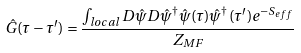Convert formula to latex. <formula><loc_0><loc_0><loc_500><loc_500>\hat { G } ( \tau - \tau ^ { \prime } ) = \frac { \int _ { l o c a l } D \hat { \psi } D \hat { \psi } ^ { \dagger } \hat { \psi } ( \tau ) \hat { \psi } ^ { \dagger } ( \tau ^ { \prime } ) e ^ { - S _ { e f f } } } { Z _ { M F } }</formula> 